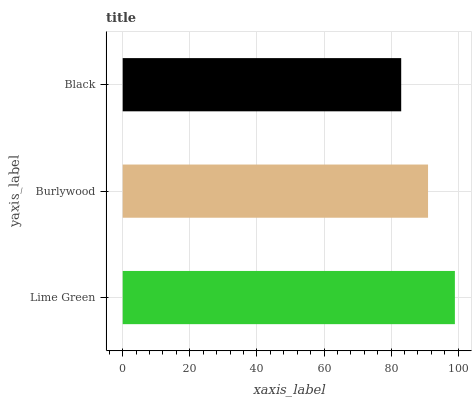Is Black the minimum?
Answer yes or no. Yes. Is Lime Green the maximum?
Answer yes or no. Yes. Is Burlywood the minimum?
Answer yes or no. No. Is Burlywood the maximum?
Answer yes or no. No. Is Lime Green greater than Burlywood?
Answer yes or no. Yes. Is Burlywood less than Lime Green?
Answer yes or no. Yes. Is Burlywood greater than Lime Green?
Answer yes or no. No. Is Lime Green less than Burlywood?
Answer yes or no. No. Is Burlywood the high median?
Answer yes or no. Yes. Is Burlywood the low median?
Answer yes or no. Yes. Is Black the high median?
Answer yes or no. No. Is Black the low median?
Answer yes or no. No. 